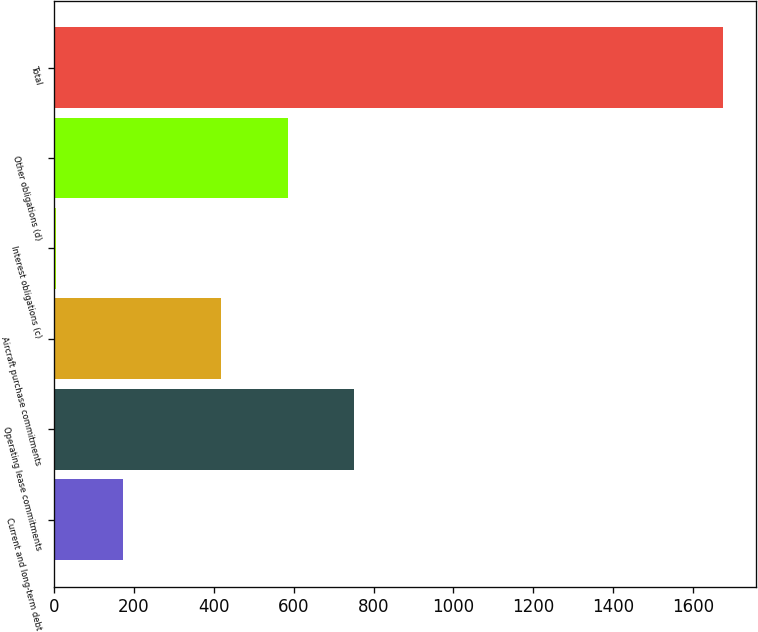Convert chart to OTSL. <chart><loc_0><loc_0><loc_500><loc_500><bar_chart><fcel>Current and long-term debt<fcel>Operating lease commitments<fcel>Aircraft purchase commitments<fcel>Interest obligations (c)<fcel>Other obligations (d)<fcel>Total<nl><fcel>172<fcel>752<fcel>418<fcel>5<fcel>585<fcel>1675<nl></chart> 